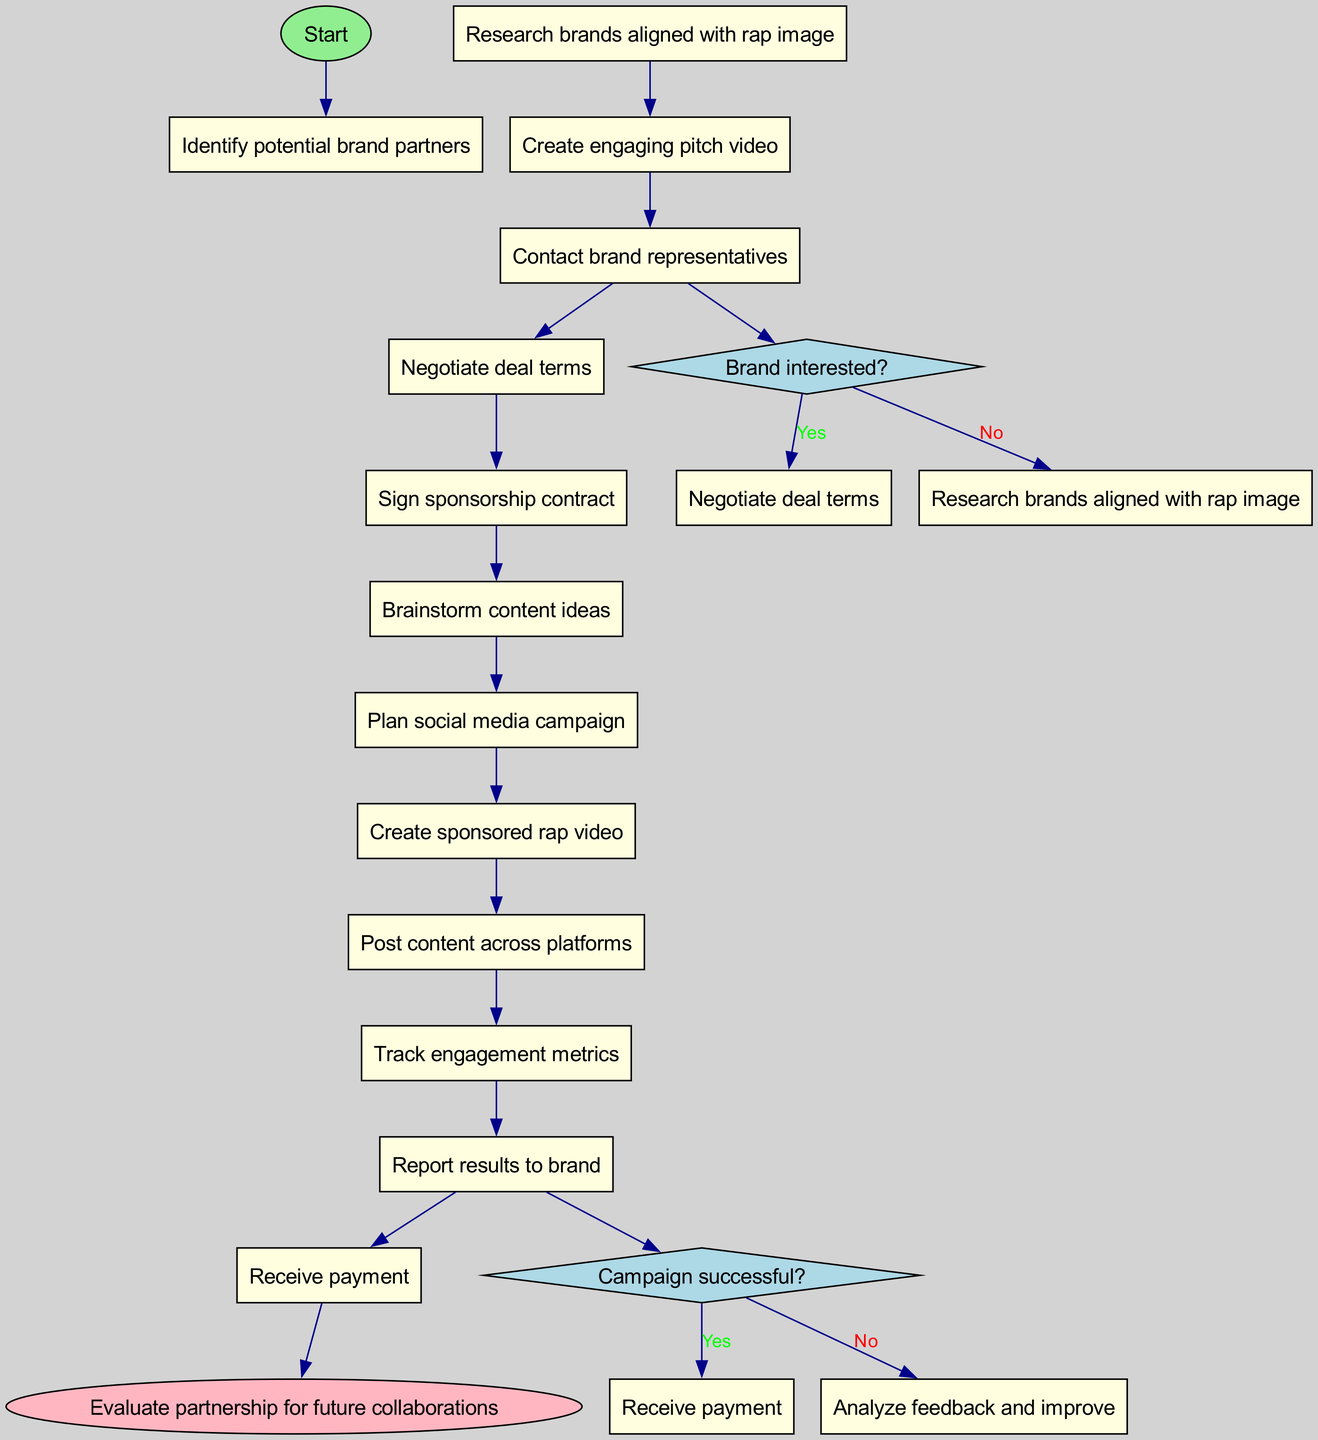What is the starting activity in the diagram? The starting activity is indicated at the first node directly following the 'Start' node. It is labeled "Identify potential brand partners."
Answer: Identify potential brand partners How many activities are there in total? By counting the list of activities provided in the diagram, there are a total of 12 activities.
Answer: 12 What is the decision condition before negotiating deal terms? The decision node before negotiating deal terms checks if the brand is interested. If they are not interested, it loops back to research brands.
Answer: Brand interested? What is the last activity before receiving payment? To find the last activity before receiving payment, we can trace the flow back from the 'Receive payment' node to see which activity leads into it. That activity is "Report results to brand."
Answer: Report results to brand What happens if the campaign is declared successful? If the campaign is successful, the next action specified in the diagram is to "Receive payment." Thus, success leads directly to payment.
Answer: Receive payment What activity occurs after creating the sponsored rap video? Following the creation of the sponsored rap video, the next activity in the diagram is to "Post content across platforms."
Answer: Post content across platforms What is the final node in the diagram? The final node is labeled as "Evaluate partnership for future collaborations," which indicates the closing phase of the process.
Answer: Evaluate partnership for future collaborations If the brand is not interested, what is the next step? If the brand is not interested, the process directs back to "Research brands aligned with rap image," guiding the flow to look for a different brand partner.
Answer: Research brands aligned with rap image What action follows "Track engagement metrics"? After tracking engagement metrics, the next action is to "Report results to brand," which shows continuity towards finalizing the engagement.
Answer: Report results to brand 